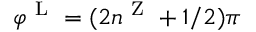<formula> <loc_0><loc_0><loc_500><loc_500>\varphi ^ { L } = ( 2 n ^ { Z } + 1 / 2 ) \pi</formula> 